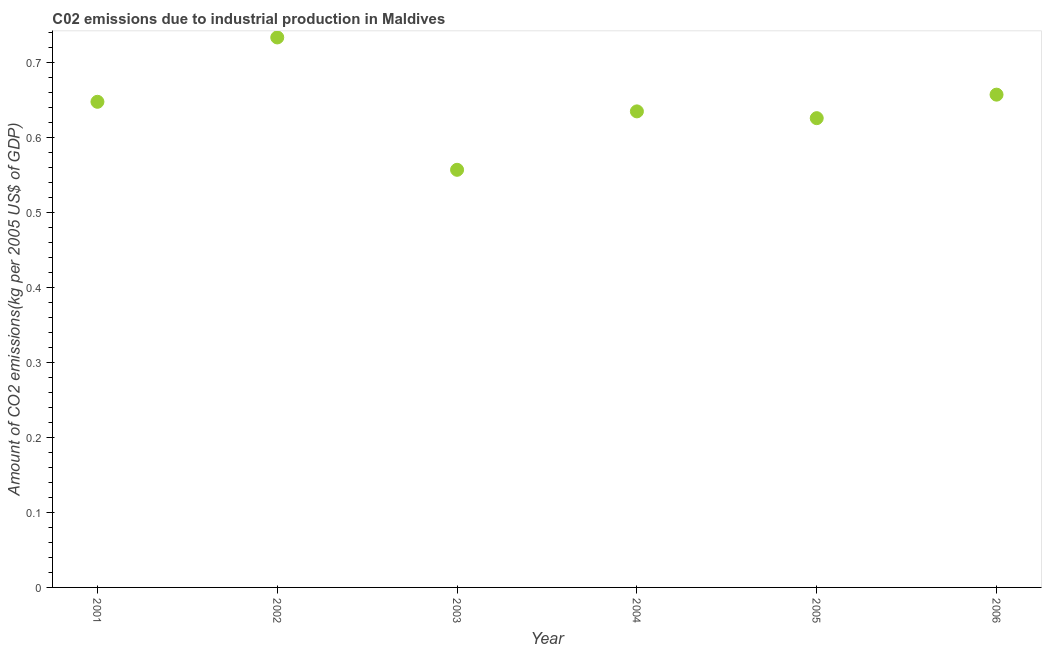What is the amount of co2 emissions in 2005?
Your answer should be compact. 0.63. Across all years, what is the maximum amount of co2 emissions?
Your answer should be very brief. 0.73. Across all years, what is the minimum amount of co2 emissions?
Provide a succinct answer. 0.56. In which year was the amount of co2 emissions minimum?
Your answer should be very brief. 2003. What is the sum of the amount of co2 emissions?
Offer a very short reply. 3.85. What is the difference between the amount of co2 emissions in 2003 and 2004?
Offer a terse response. -0.08. What is the average amount of co2 emissions per year?
Your answer should be compact. 0.64. What is the median amount of co2 emissions?
Your answer should be compact. 0.64. What is the ratio of the amount of co2 emissions in 2001 to that in 2005?
Ensure brevity in your answer.  1.03. Is the amount of co2 emissions in 2002 less than that in 2005?
Your response must be concise. No. Is the difference between the amount of co2 emissions in 2003 and 2006 greater than the difference between any two years?
Provide a short and direct response. No. What is the difference between the highest and the second highest amount of co2 emissions?
Give a very brief answer. 0.08. Is the sum of the amount of co2 emissions in 2001 and 2005 greater than the maximum amount of co2 emissions across all years?
Provide a short and direct response. Yes. What is the difference between the highest and the lowest amount of co2 emissions?
Ensure brevity in your answer.  0.18. In how many years, is the amount of co2 emissions greater than the average amount of co2 emissions taken over all years?
Keep it short and to the point. 3. What is the difference between two consecutive major ticks on the Y-axis?
Provide a succinct answer. 0.1. Are the values on the major ticks of Y-axis written in scientific E-notation?
Your answer should be compact. No. What is the title of the graph?
Make the answer very short. C02 emissions due to industrial production in Maldives. What is the label or title of the Y-axis?
Your response must be concise. Amount of CO2 emissions(kg per 2005 US$ of GDP). What is the Amount of CO2 emissions(kg per 2005 US$ of GDP) in 2001?
Offer a terse response. 0.65. What is the Amount of CO2 emissions(kg per 2005 US$ of GDP) in 2002?
Offer a very short reply. 0.73. What is the Amount of CO2 emissions(kg per 2005 US$ of GDP) in 2003?
Provide a succinct answer. 0.56. What is the Amount of CO2 emissions(kg per 2005 US$ of GDP) in 2004?
Give a very brief answer. 0.63. What is the Amount of CO2 emissions(kg per 2005 US$ of GDP) in 2005?
Your answer should be compact. 0.63. What is the Amount of CO2 emissions(kg per 2005 US$ of GDP) in 2006?
Your answer should be compact. 0.66. What is the difference between the Amount of CO2 emissions(kg per 2005 US$ of GDP) in 2001 and 2002?
Provide a succinct answer. -0.09. What is the difference between the Amount of CO2 emissions(kg per 2005 US$ of GDP) in 2001 and 2003?
Offer a terse response. 0.09. What is the difference between the Amount of CO2 emissions(kg per 2005 US$ of GDP) in 2001 and 2004?
Offer a very short reply. 0.01. What is the difference between the Amount of CO2 emissions(kg per 2005 US$ of GDP) in 2001 and 2005?
Offer a very short reply. 0.02. What is the difference between the Amount of CO2 emissions(kg per 2005 US$ of GDP) in 2001 and 2006?
Ensure brevity in your answer.  -0.01. What is the difference between the Amount of CO2 emissions(kg per 2005 US$ of GDP) in 2002 and 2003?
Keep it short and to the point. 0.18. What is the difference between the Amount of CO2 emissions(kg per 2005 US$ of GDP) in 2002 and 2004?
Your answer should be very brief. 0.1. What is the difference between the Amount of CO2 emissions(kg per 2005 US$ of GDP) in 2002 and 2005?
Keep it short and to the point. 0.11. What is the difference between the Amount of CO2 emissions(kg per 2005 US$ of GDP) in 2002 and 2006?
Keep it short and to the point. 0.08. What is the difference between the Amount of CO2 emissions(kg per 2005 US$ of GDP) in 2003 and 2004?
Offer a very short reply. -0.08. What is the difference between the Amount of CO2 emissions(kg per 2005 US$ of GDP) in 2003 and 2005?
Provide a short and direct response. -0.07. What is the difference between the Amount of CO2 emissions(kg per 2005 US$ of GDP) in 2003 and 2006?
Give a very brief answer. -0.1. What is the difference between the Amount of CO2 emissions(kg per 2005 US$ of GDP) in 2004 and 2005?
Make the answer very short. 0.01. What is the difference between the Amount of CO2 emissions(kg per 2005 US$ of GDP) in 2004 and 2006?
Ensure brevity in your answer.  -0.02. What is the difference between the Amount of CO2 emissions(kg per 2005 US$ of GDP) in 2005 and 2006?
Give a very brief answer. -0.03. What is the ratio of the Amount of CO2 emissions(kg per 2005 US$ of GDP) in 2001 to that in 2002?
Your response must be concise. 0.88. What is the ratio of the Amount of CO2 emissions(kg per 2005 US$ of GDP) in 2001 to that in 2003?
Give a very brief answer. 1.16. What is the ratio of the Amount of CO2 emissions(kg per 2005 US$ of GDP) in 2001 to that in 2005?
Make the answer very short. 1.03. What is the ratio of the Amount of CO2 emissions(kg per 2005 US$ of GDP) in 2002 to that in 2003?
Offer a very short reply. 1.32. What is the ratio of the Amount of CO2 emissions(kg per 2005 US$ of GDP) in 2002 to that in 2004?
Offer a very short reply. 1.16. What is the ratio of the Amount of CO2 emissions(kg per 2005 US$ of GDP) in 2002 to that in 2005?
Your response must be concise. 1.17. What is the ratio of the Amount of CO2 emissions(kg per 2005 US$ of GDP) in 2002 to that in 2006?
Provide a succinct answer. 1.12. What is the ratio of the Amount of CO2 emissions(kg per 2005 US$ of GDP) in 2003 to that in 2004?
Your answer should be compact. 0.88. What is the ratio of the Amount of CO2 emissions(kg per 2005 US$ of GDP) in 2003 to that in 2005?
Give a very brief answer. 0.89. What is the ratio of the Amount of CO2 emissions(kg per 2005 US$ of GDP) in 2003 to that in 2006?
Offer a terse response. 0.85. 